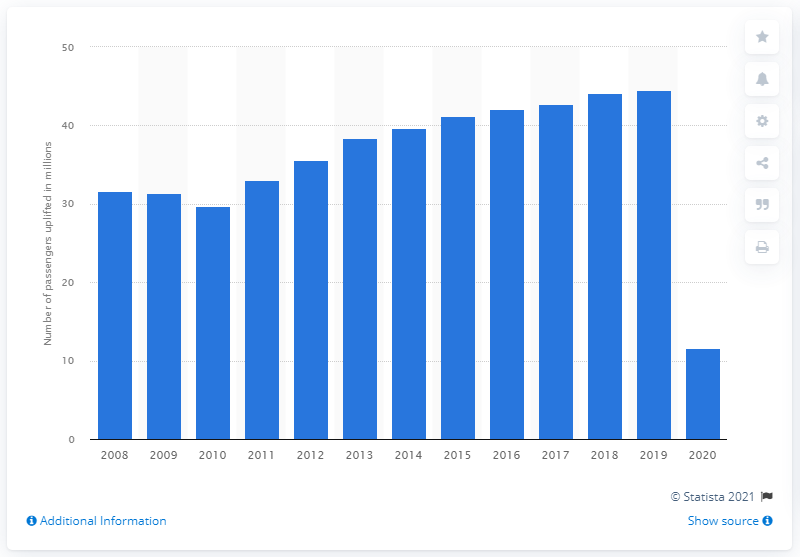Highlight a few significant elements in this photo. Until 2020, British Airways had uplifted a total of 11,660 passengers. 